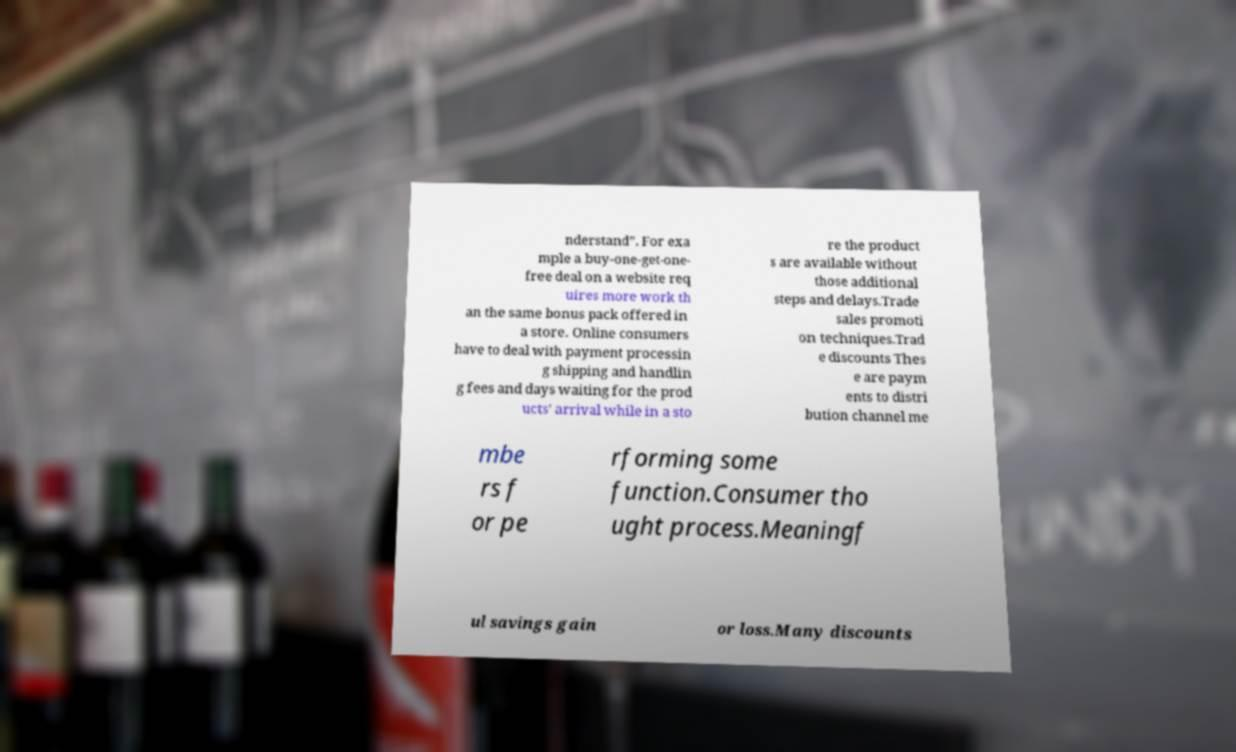Please identify and transcribe the text found in this image. nderstand”. For exa mple a buy-one-get-one- free deal on a website req uires more work th an the same bonus pack offered in a store. Online consumers have to deal with payment processin g shipping and handlin g fees and days waiting for the prod ucts’ arrival while in a sto re the product s are available without those additional steps and delays.Trade sales promoti on techniques.Trad e discounts Thes e are paym ents to distri bution channel me mbe rs f or pe rforming some function.Consumer tho ught process.Meaningf ul savings gain or loss.Many discounts 